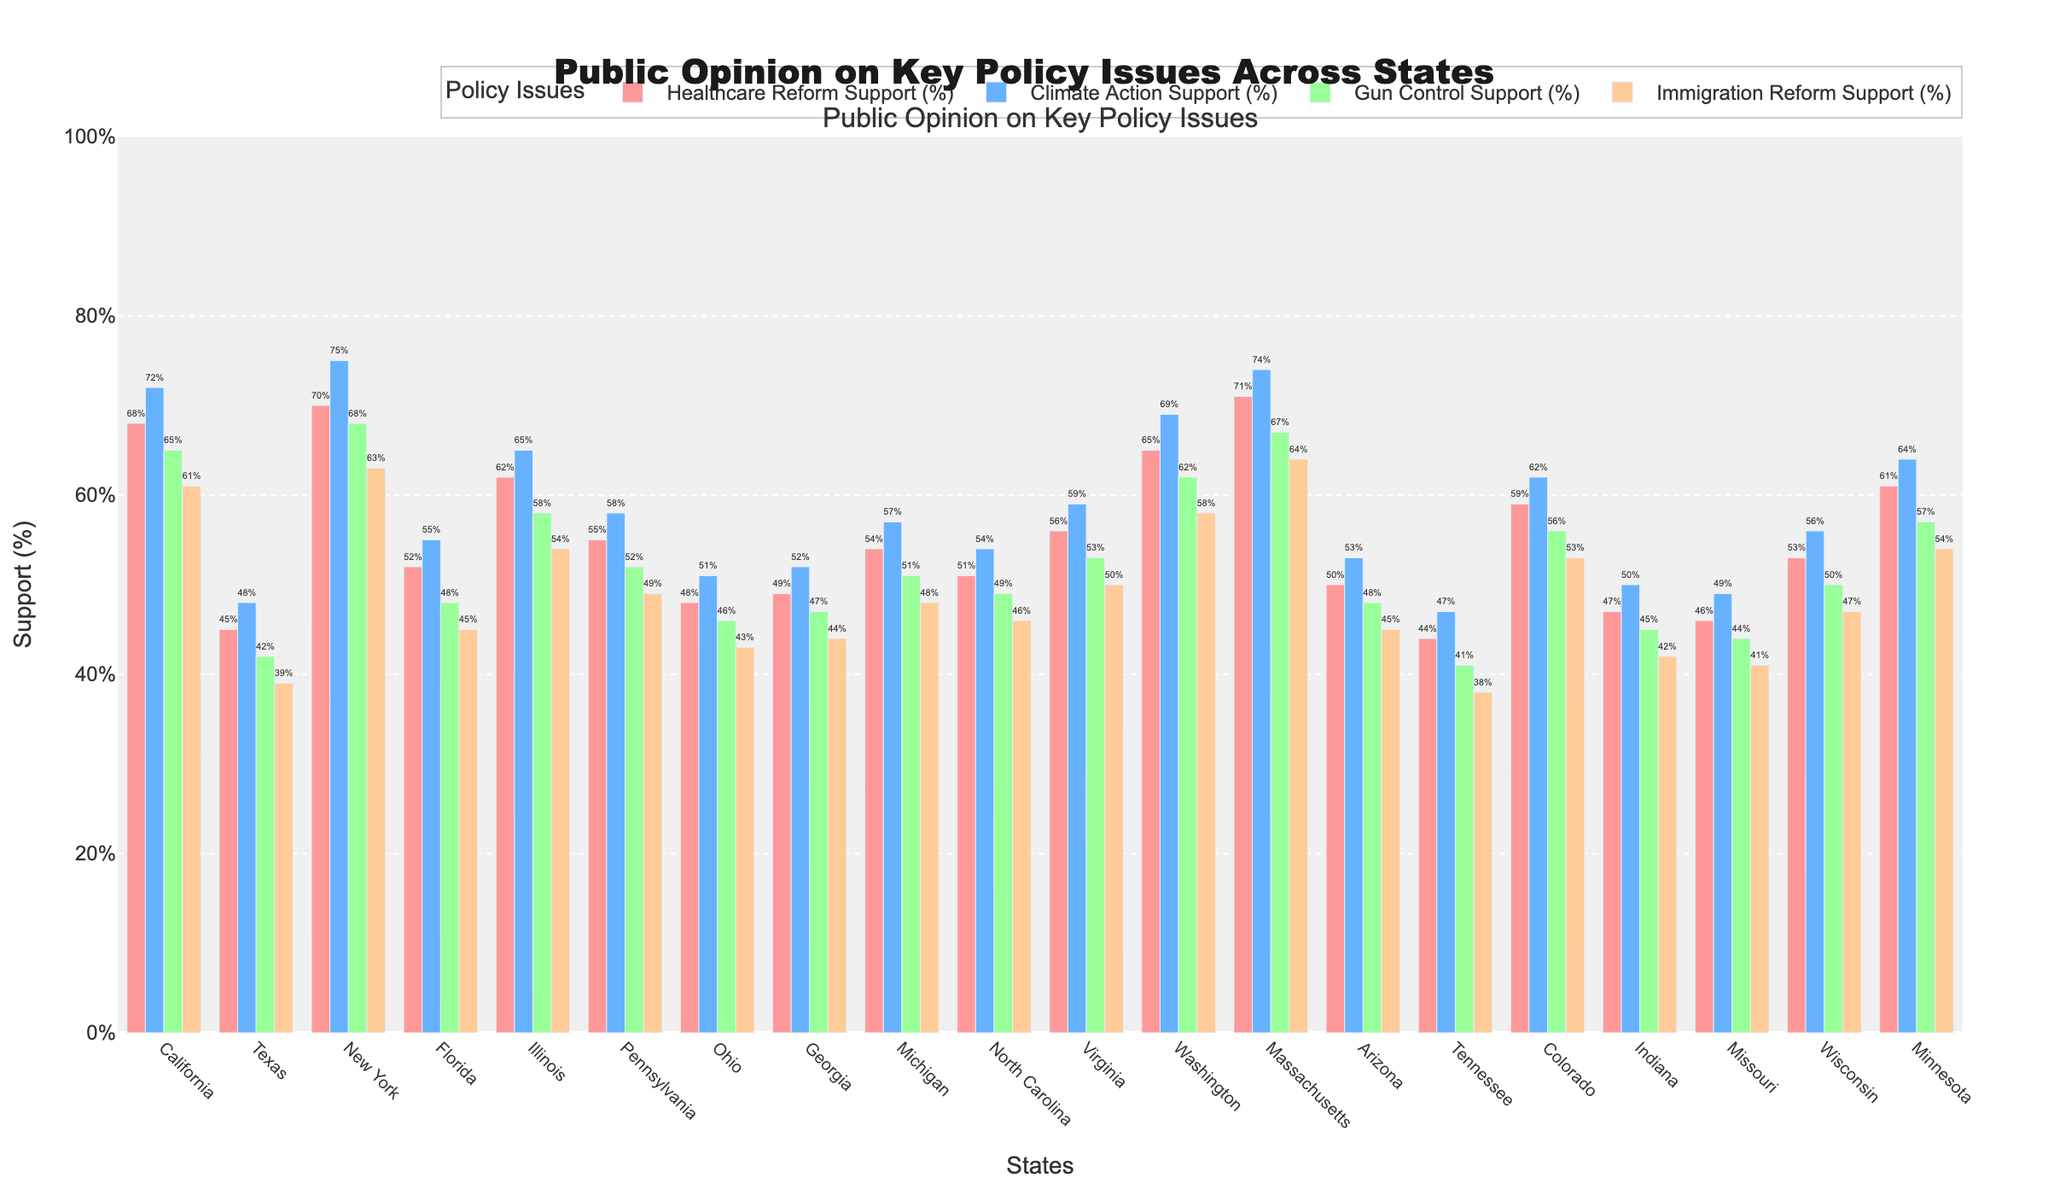What state has the highest support for Climate Action? To identify the state with the highest support for Climate Action, look for the tallest blue bar on the chart. Here, New York has the highest Climate Action support.
Answer: New York Which state shows the lowest support for Immigration Reform? To find the state with the lowest support for Immigration Reform, locate the shortest orange bar on the chart. Tennessee has the lowest support for Immigration Reform.
Answer: Tennessee Compare the support for Gun Control between New York and Texas. Which state has higher support, and by how much? New York's Gun Control support percentage is 68%, while Texas has 42%. Therefore, New York has a higher support by \( 68 - 42 \)% which is 26%.
Answer: New York by 26% What is the average support for Healthcare Reform across all states? Sum the percentages of Healthcare Reform support for all states and divide by the total number of states. The sum is \( 68 + 45 + 70 + 52 + 62 + 55 + 48 + 49 + 54 + 51 + 56 + 65 + 71 + 50 + 44 + 59 + 47 + 46 + 53 + 61 \) which is 1072. Divide by the number of states which is 20. Therefore, the average is \( \frac{1072}{20} \) which equals 53.6%.
Answer: 53.6% Which policy issue has the most consistent support across all states? Consistency can be thought of as having less variation in support percentages. Look at the bars of each policy issue and observe their heights. Climate Action Support seems to have the most evenly spread heights across states.
Answer: Climate Action In which state is the support for Climate Action closest to the support for Gun Control? Find the state where the difference between Climate Action and Gun Control support is smallest. For Michigan, Climate Action is 57% and Gun Control is 51% with a difference of \( 57 - 51 = 6 \). Compare with other states and confirm.
Answer: Michigan What is the total support for all policy issues in California? Sum the support percentages of all policy issues in California. The values are 68% for Healthcare Reform, 72% for Climate Action, 65% for Gun Control, and 61% for Immigration Reform. So, \( 68 + 72 + 65 + 61 = 266 \).
Answer: 266% Which state has a greater support for Healthcare Reform, Virginia or Wisconsin, and by how much? Virginia has 56% support, while Wisconsin has 53% for Healthcare Reform. Virginia's support is greater by \( 56 - 53 = 3 \)%.
Answer: Virginia by 3% Is there any state where the support for all four policy issues is below 50%? Examine the bars for each state. Texas, Tennessee, and Indiana have bars for all issues below 50%.
Answer: Texas, Tennessee, Indiana 